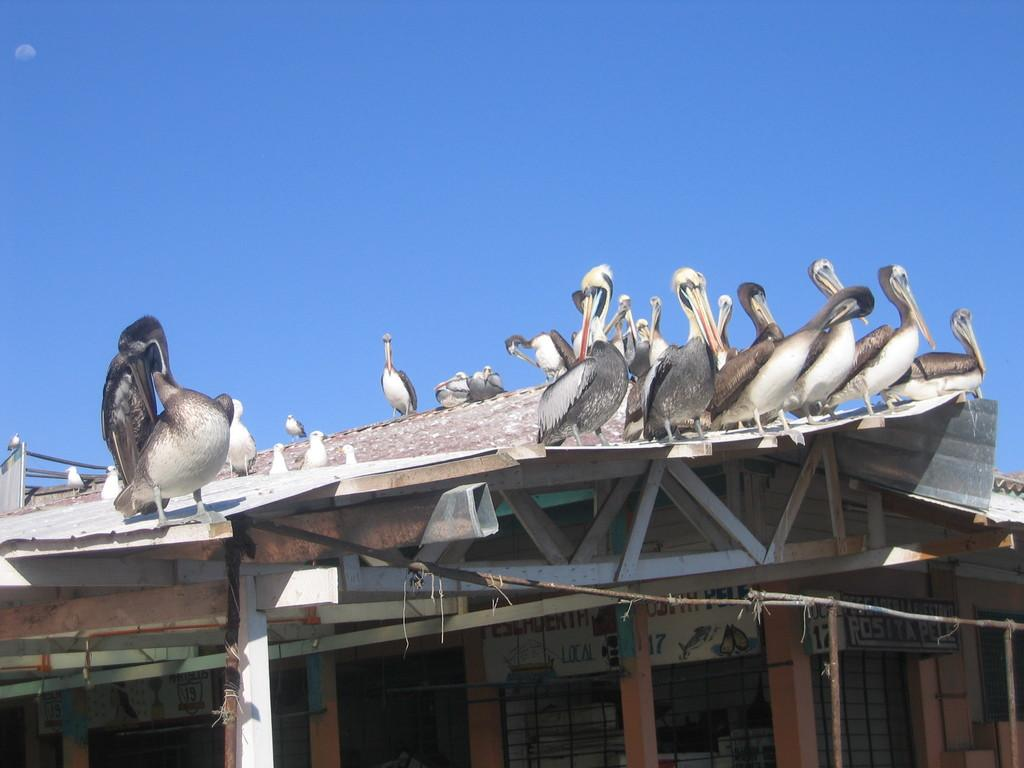What structure is located at the bottom of the image? There is a shed at the bottom of the image. What can be seen on the shed in the image? Birds are present on the roof of the shed. What is visible at the top of the image? The sky is visible at the top of the image. What type of plantation can be seen growing near the shed in the image? There is no plantation present in the image; it only features a shed with birds on its roof and the sky visible at the top. 